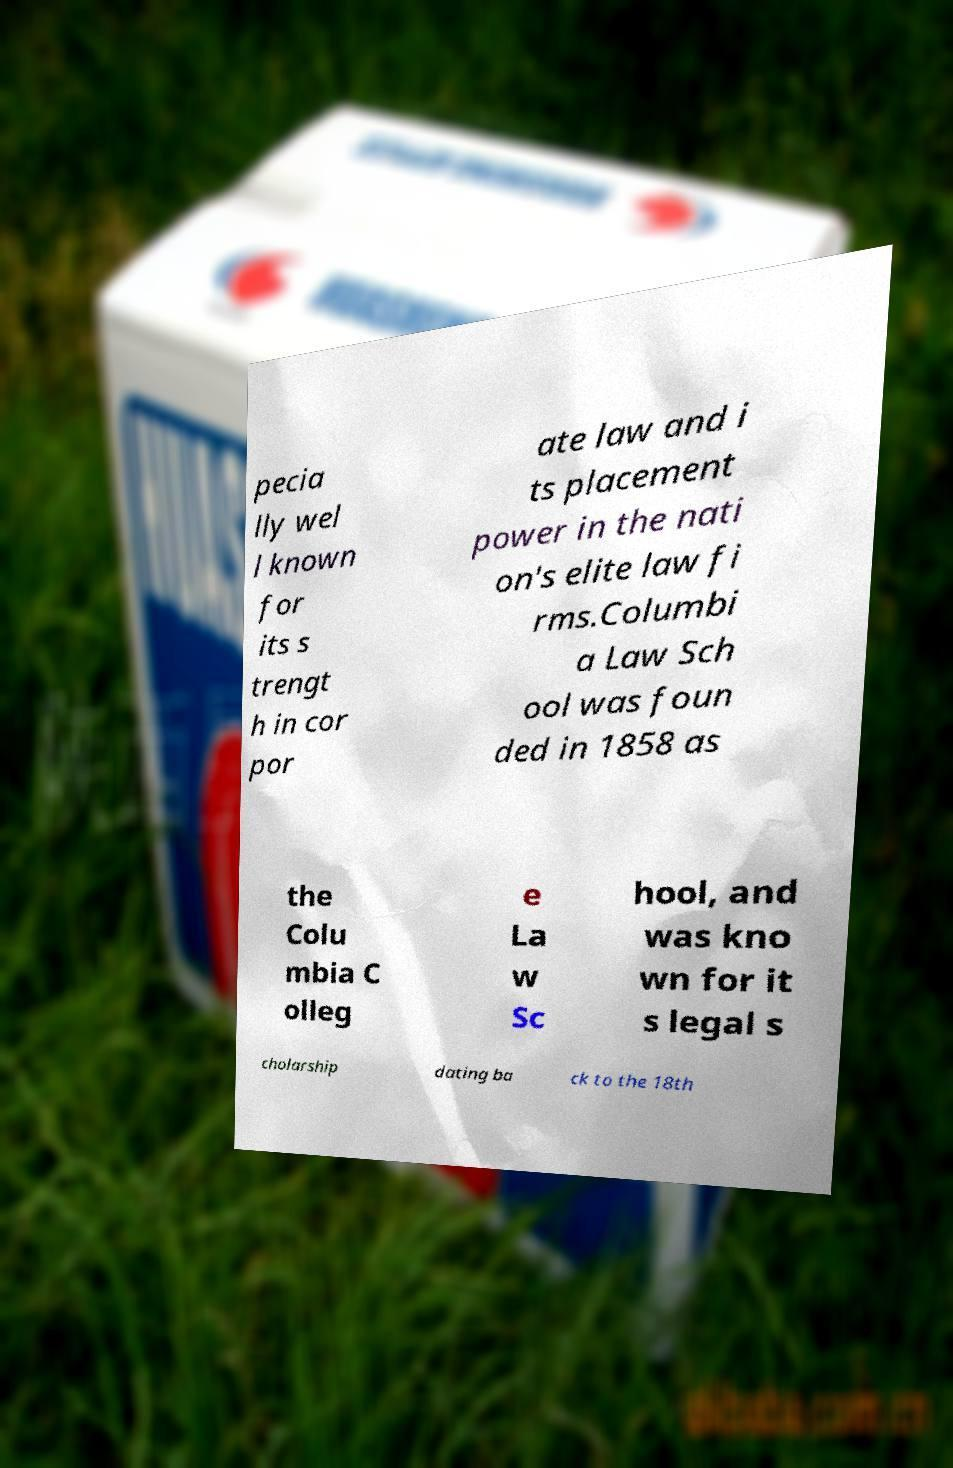Can you read and provide the text displayed in the image?This photo seems to have some interesting text. Can you extract and type it out for me? pecia lly wel l known for its s trengt h in cor por ate law and i ts placement power in the nati on's elite law fi rms.Columbi a Law Sch ool was foun ded in 1858 as the Colu mbia C olleg e La w Sc hool, and was kno wn for it s legal s cholarship dating ba ck to the 18th 